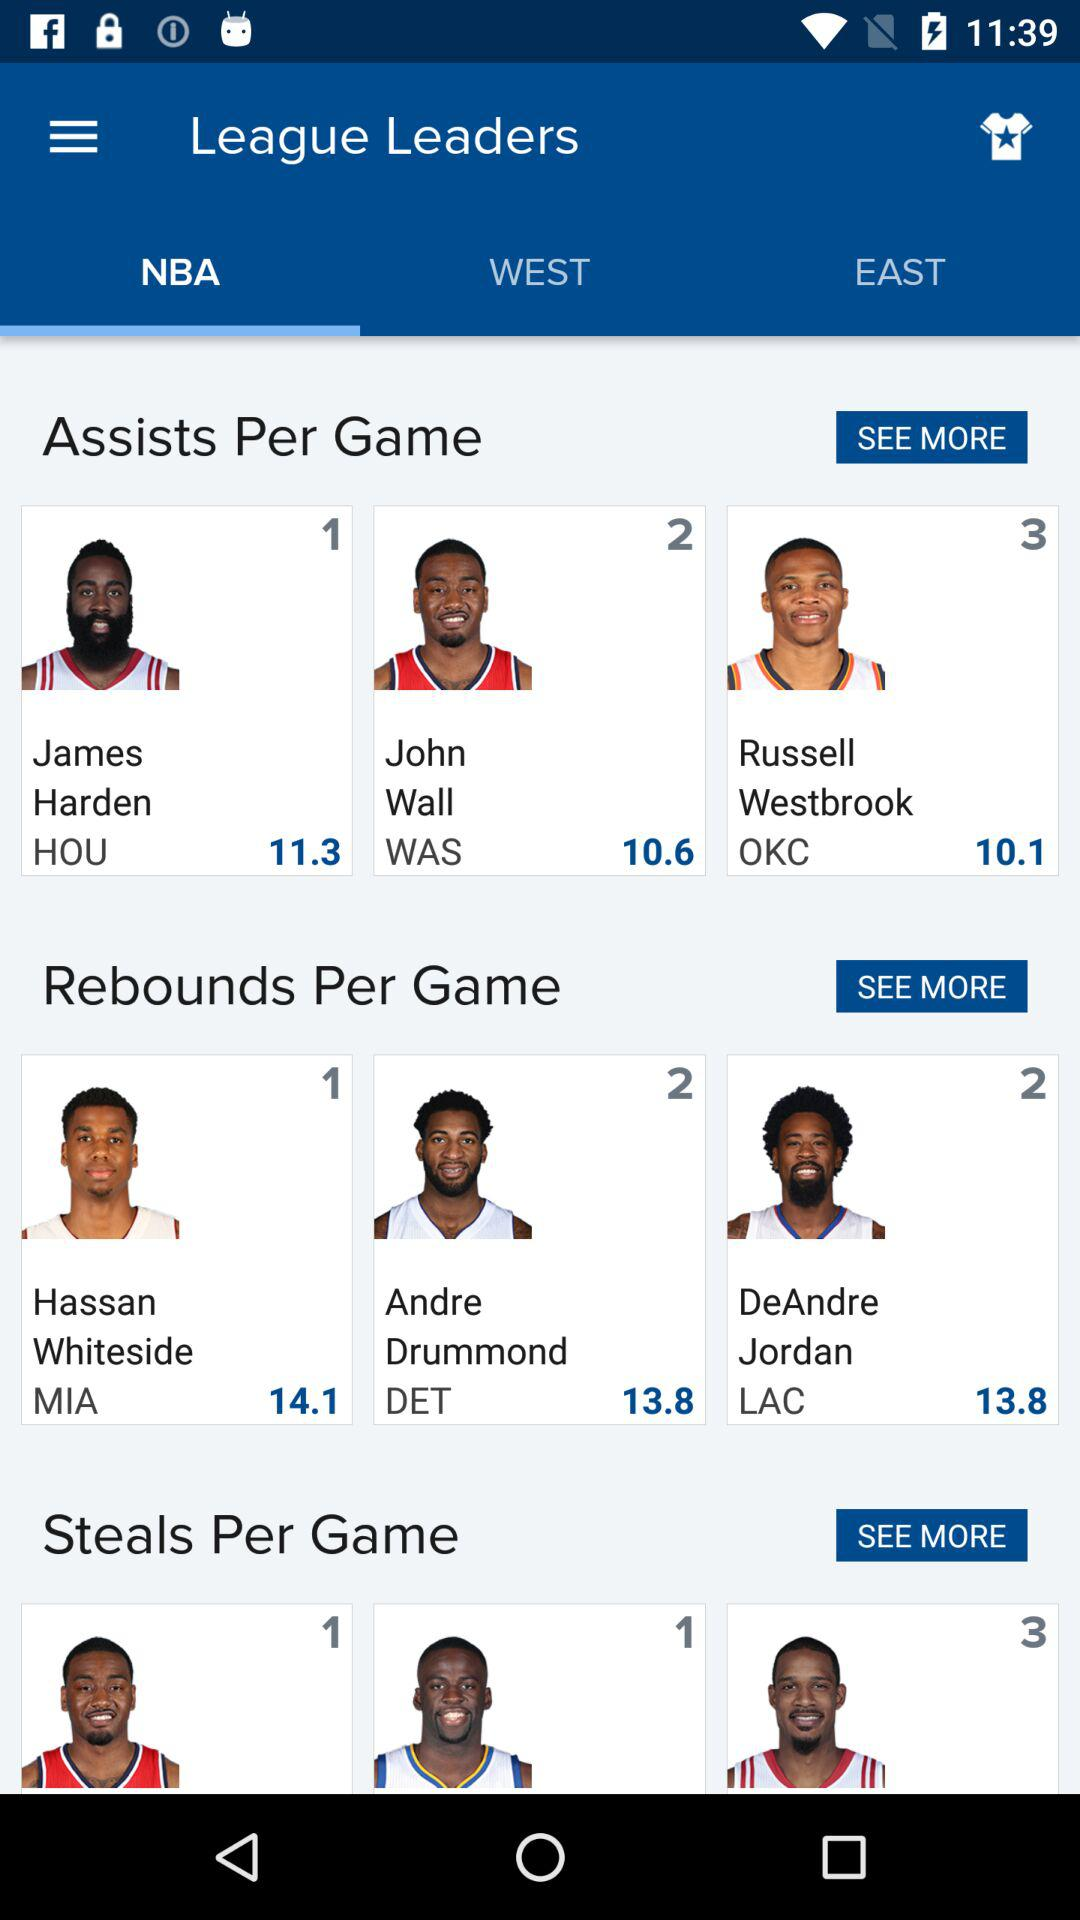What is the number of points scored by John Wall? The number of points scored by John Wall is 10.6. 